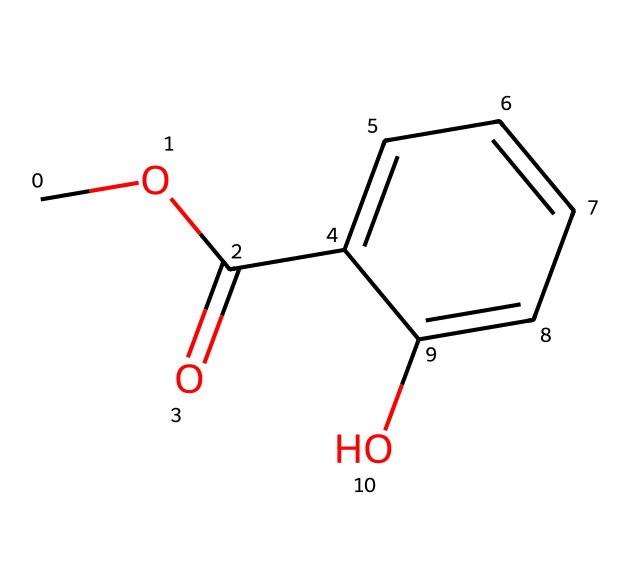What is the molecular formula of methyl salicylate? To deduce the molecular formula, we identify the elements in the chemical structure. From the SMILES representation, we count the carbon (C), hydrogen (H), and oxygen (O) atoms. There are 9 carbon atoms, 10 hydrogen atoms, and 3 oxygen atoms, leading to the formula C9H10O3.
Answer: C9H10O3 How many carbon atoms are present in methyl salicylate? The SMILES shows that carbon atoms appear in the structure, specifically there are 9 distinct carbon atoms counted directly from the molecular formula interpretation.
Answer: 9 What functional group defines methyl salicylate as an ester? Methyl salicylate has a carbonyl group (C=O) bonded to an oxygen atom that is attached to a methyl group (–OCH3) and a phenolic structure, characteristic of esters. This functional group is responsible for its classification as an ester.
Answer: ester Does methyl salicylate contain an aromatic ring? The structure includes a benzene ring, indicated by the presence of six carbon atoms connected in a cyclic manner, which confirms the presence of an aromatic ring.
Answer: yes What property allows methyl salicylate to be effective in pain relief? The presence of the carboxylate structure in methyl salicylate is associated with anti-inflammatory properties, as well as its penetration through the skin to provide relief, which is characteristic of salicylates.
Answer: anti-inflammatory How many oxygen atoms are in the chemical structure of methyl salicylate? The SMILES notation reveals three oxygen atoms, which can be confirmed by examining the structure and counting the O's in the chemical formula provided.
Answer: 3 